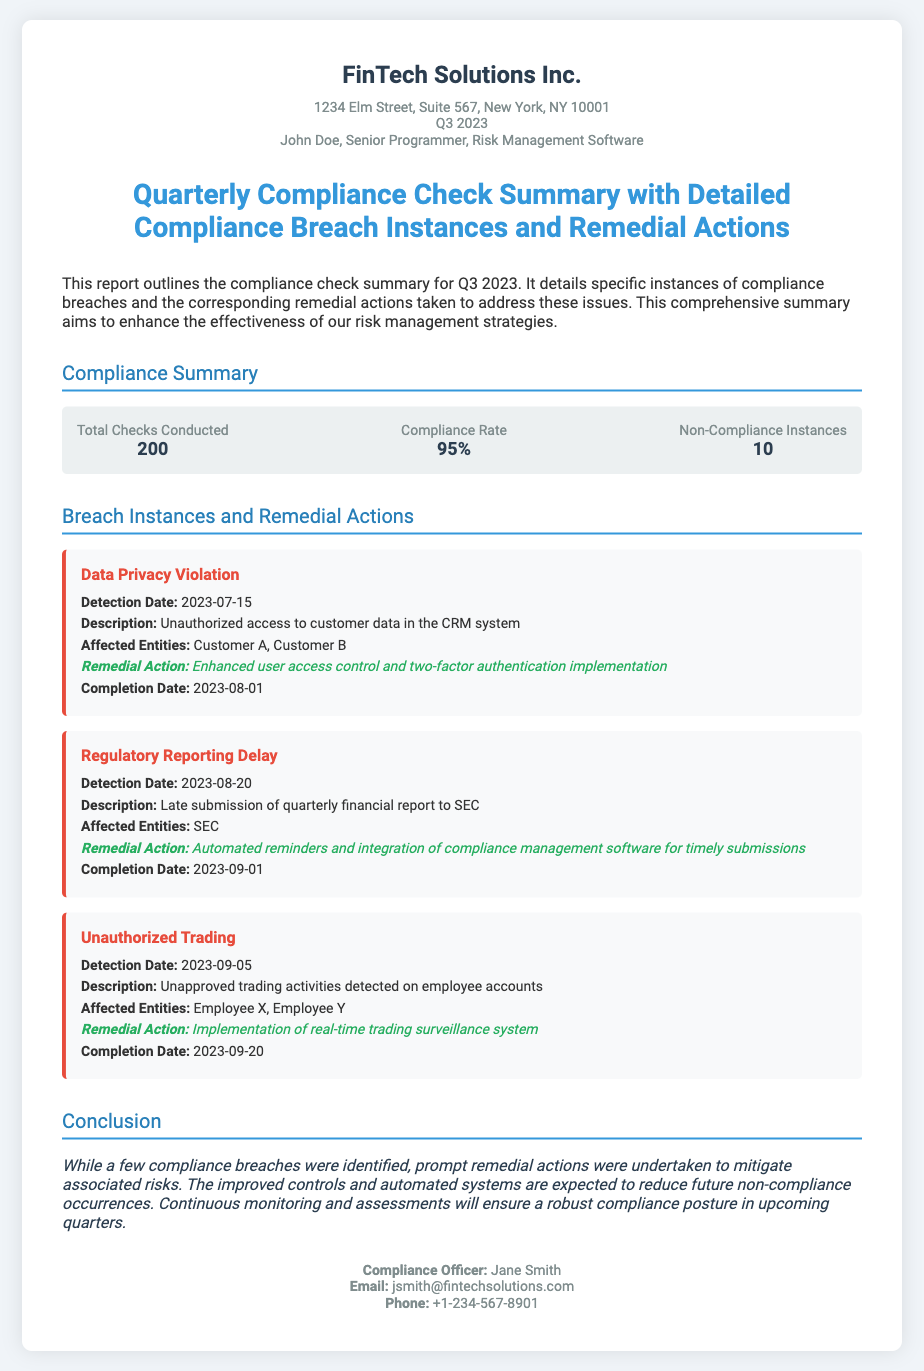What is the total number of checks conducted? The total number of checks conducted is stated in the compliance summary section.
Answer: 200 What is the compliance rate for Q3 2023? The compliance rate is mentioned as a percentage in the summary box.
Answer: 95% How many non-compliance instances were reported? The number of non-compliance instances is given directly in the summary box.
Answer: 10 What is the detection date of the Data Privacy Violation? The detection date is listed in the details of the breach instance.
Answer: 2023-07-15 What remedial action was taken for the Regulatory Reporting Delay? The remedial action is specified in the breach instance details.
Answer: Automated reminders and integration of compliance management software for timely submissions What type of breach was detected on September 5th, 2023? The type of breach is described in the breach instances section.
Answer: Unauthorized Trading Who is the Compliance Officer? The name of the Compliance Officer is provided in the contact information section.
Answer: Jane Smith What was the completion date for the remedial action related to Data Privacy Violation? The completion date for the action is stated in the breach item details.
Answer: 2023-08-01 What is the purpose of this report? The purpose of the report is summarized in the introduction section of the document.
Answer: Enhance the effectiveness of our risk management strategies 